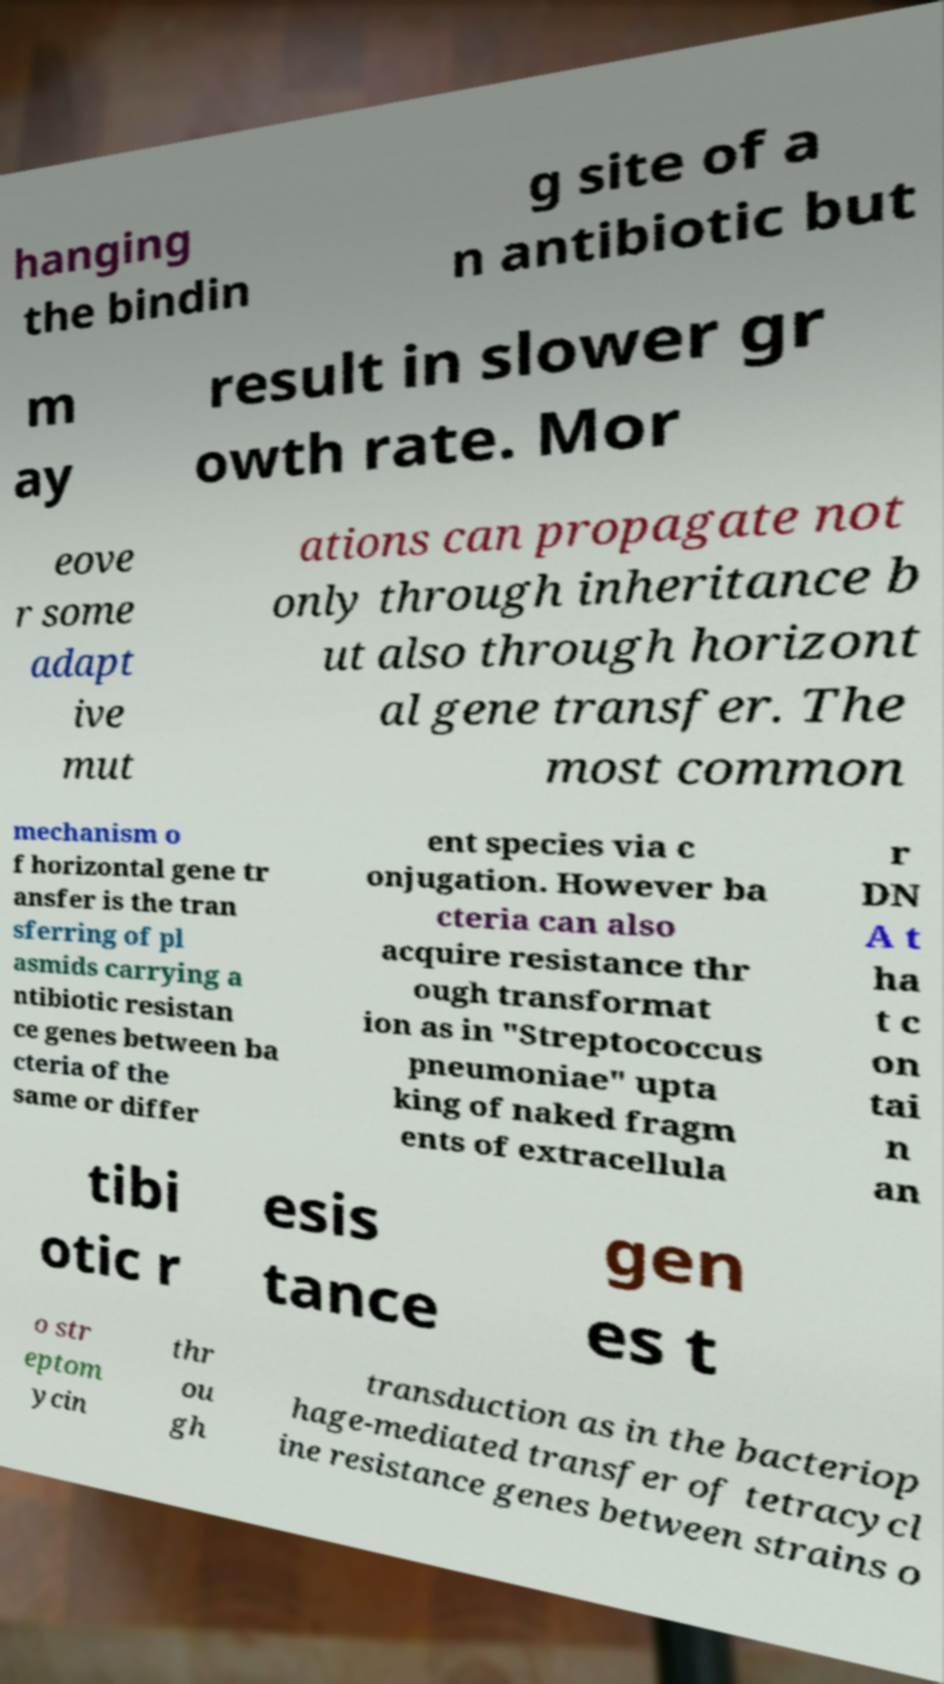For documentation purposes, I need the text within this image transcribed. Could you provide that? hanging the bindin g site of a n antibiotic but m ay result in slower gr owth rate. Mor eove r some adapt ive mut ations can propagate not only through inheritance b ut also through horizont al gene transfer. The most common mechanism o f horizontal gene tr ansfer is the tran sferring of pl asmids carrying a ntibiotic resistan ce genes between ba cteria of the same or differ ent species via c onjugation. However ba cteria can also acquire resistance thr ough transformat ion as in "Streptococcus pneumoniae" upta king of naked fragm ents of extracellula r DN A t ha t c on tai n an tibi otic r esis tance gen es t o str eptom ycin thr ou gh transduction as in the bacteriop hage-mediated transfer of tetracycl ine resistance genes between strains o 